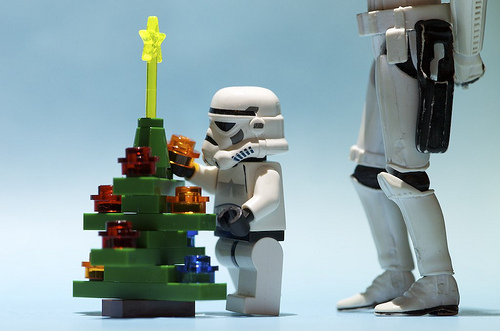<image>
Is there a tree behind the figure? No. The tree is not behind the figure. From this viewpoint, the tree appears to be positioned elsewhere in the scene. Where is the christmas tree in relation to the storm trooper? Is it in front of the storm trooper? Yes. The christmas tree is positioned in front of the storm trooper, appearing closer to the camera viewpoint. 